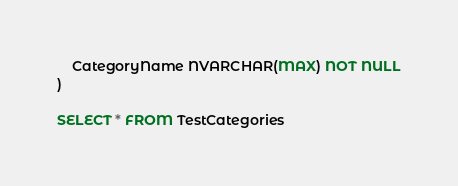<code> <loc_0><loc_0><loc_500><loc_500><_SQL_>	CategoryName NVARCHAR(MAX) NOT NULL
)

SELECT * FROM TestCategories</code> 